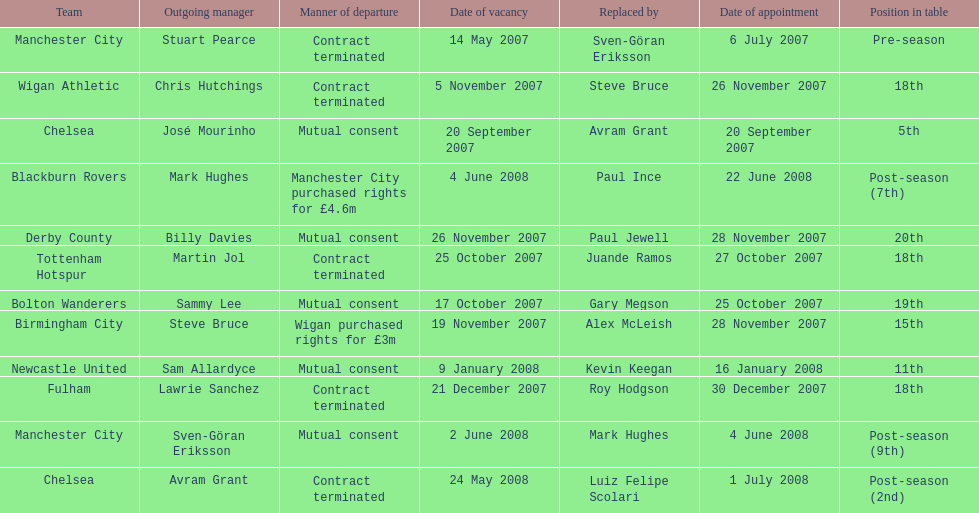What was the exclusive team to finish 5th referred to as? Chelsea. 